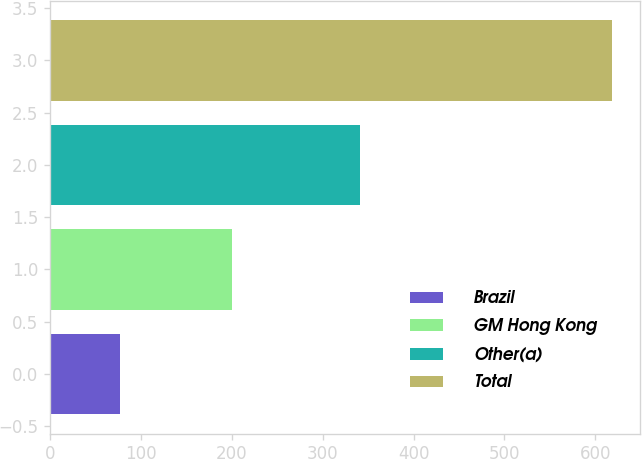<chart> <loc_0><loc_0><loc_500><loc_500><bar_chart><fcel>Brazil<fcel>GM Hong Kong<fcel>Other(a)<fcel>Total<nl><fcel>77<fcel>200<fcel>341<fcel>618<nl></chart> 